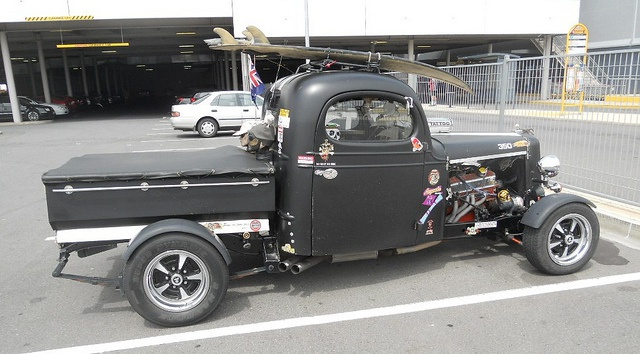Describe the objects in this image and their specific colors. I can see truck in white, gray, black, darkgray, and lightgray tones, surfboard in white, gray, darkgray, and black tones, car in white, darkgray, gray, and lightgray tones, car in white, black, gray, and darkgray tones, and car in black, gray, and white tones in this image. 